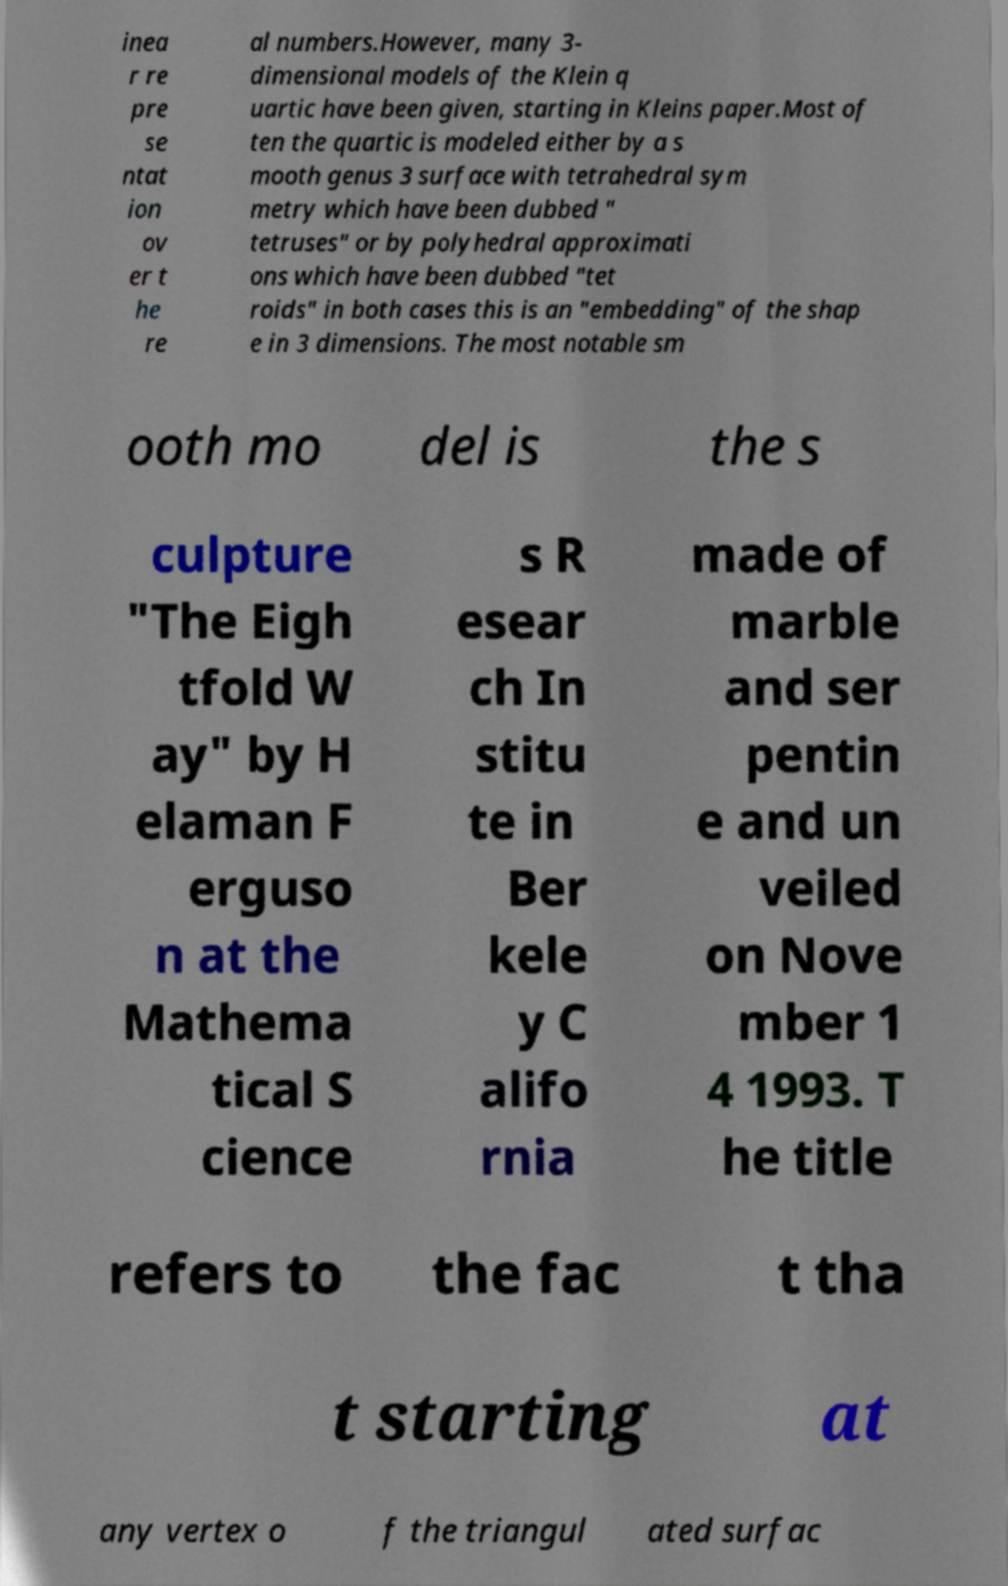Please read and relay the text visible in this image. What does it say? inea r re pre se ntat ion ov er t he re al numbers.However, many 3- dimensional models of the Klein q uartic have been given, starting in Kleins paper.Most of ten the quartic is modeled either by a s mooth genus 3 surface with tetrahedral sym metry which have been dubbed " tetruses" or by polyhedral approximati ons which have been dubbed "tet roids" in both cases this is an "embedding" of the shap e in 3 dimensions. The most notable sm ooth mo del is the s culpture "The Eigh tfold W ay" by H elaman F erguso n at the Mathema tical S cience s R esear ch In stitu te in Ber kele y C alifo rnia made of marble and ser pentin e and un veiled on Nove mber 1 4 1993. T he title refers to the fac t tha t starting at any vertex o f the triangul ated surfac 